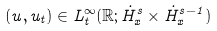Convert formula to latex. <formula><loc_0><loc_0><loc_500><loc_500>( u , u _ { t } ) \in L _ { t } ^ { \infty } ( \mathbb { R } ; \dot { H } _ { x } ^ { s } \times \dot { H } _ { x } ^ { s - 1 } )</formula> 